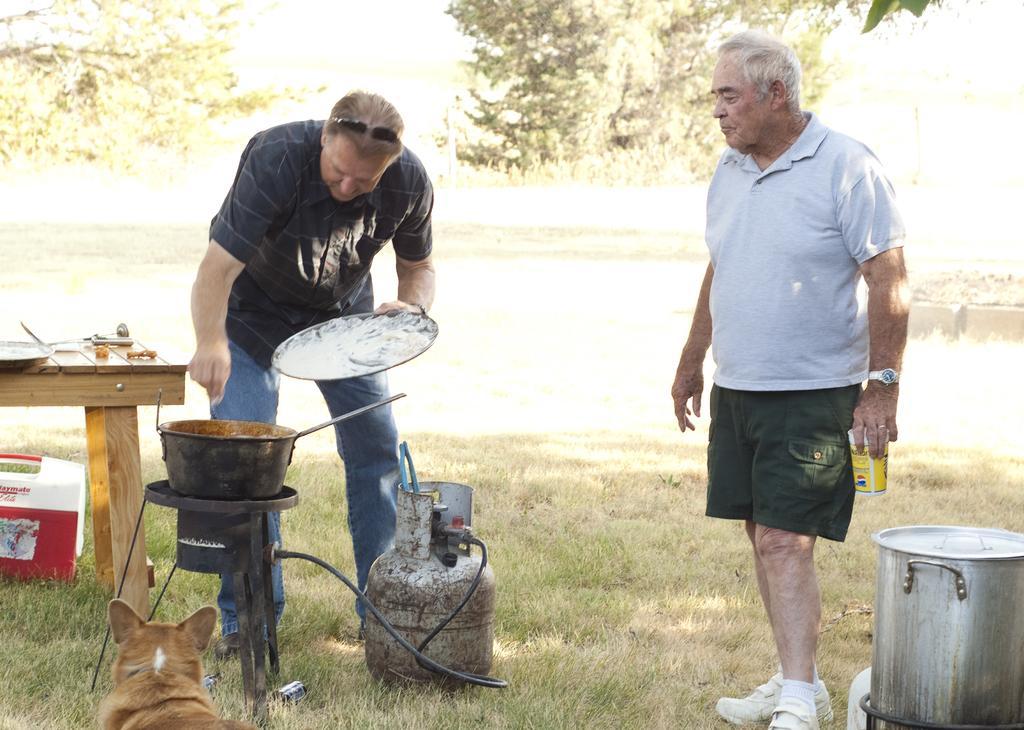Please provide a concise description of this image. In this picture we can observe two men standing. One of the men was cooking food in front of this stove. On the left side there is a brown color dog. There is a table on the left side. We can observe some grass on the ground. In the background there are trees. 